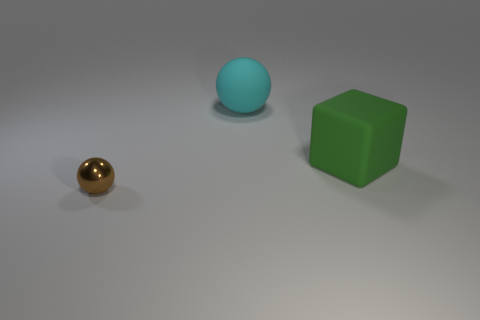What number of big cyan objects are in front of the green matte cube to the right of the cyan object?
Provide a succinct answer. 0. What number of things are behind the tiny shiny sphere and on the left side of the green block?
Ensure brevity in your answer.  1. How many other objects are the same material as the cyan thing?
Your answer should be compact. 1. There is a sphere in front of the object on the right side of the cyan thing; what is its color?
Provide a short and direct response. Brown. There is a big matte thing in front of the large matte ball; is it the same color as the metal sphere?
Offer a terse response. No. Do the green block and the metal thing have the same size?
Your answer should be compact. No. There is a rubber thing that is the same size as the cyan sphere; what is its shape?
Offer a very short reply. Cube. Does the rubber thing on the right side of the cyan matte ball have the same size as the cyan thing?
Make the answer very short. Yes. What is the material of the object that is the same size as the rubber cube?
Your answer should be compact. Rubber. Is there a green thing that is behind the ball behind the metallic sphere that is in front of the cube?
Your answer should be compact. No. 